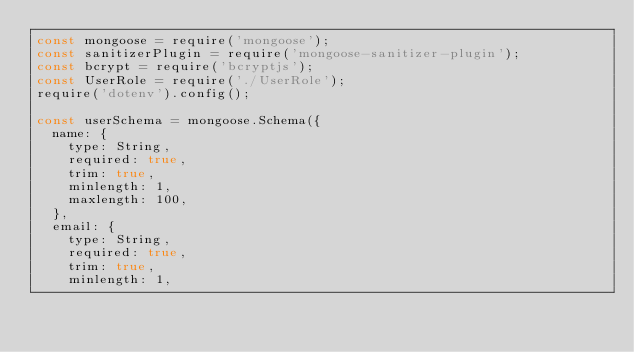Convert code to text. <code><loc_0><loc_0><loc_500><loc_500><_JavaScript_>const mongoose = require('mongoose');
const sanitizerPlugin = require('mongoose-sanitizer-plugin');
const bcrypt = require('bcryptjs');
const UserRole = require('./UserRole');
require('dotenv').config();

const userSchema = mongoose.Schema({
  name: {
    type: String,
    required: true,
    trim: true,
    minlength: 1,
    maxlength: 100,
  },
  email: {
    type: String,
    required: true,
    trim: true,
    minlength: 1,</code> 